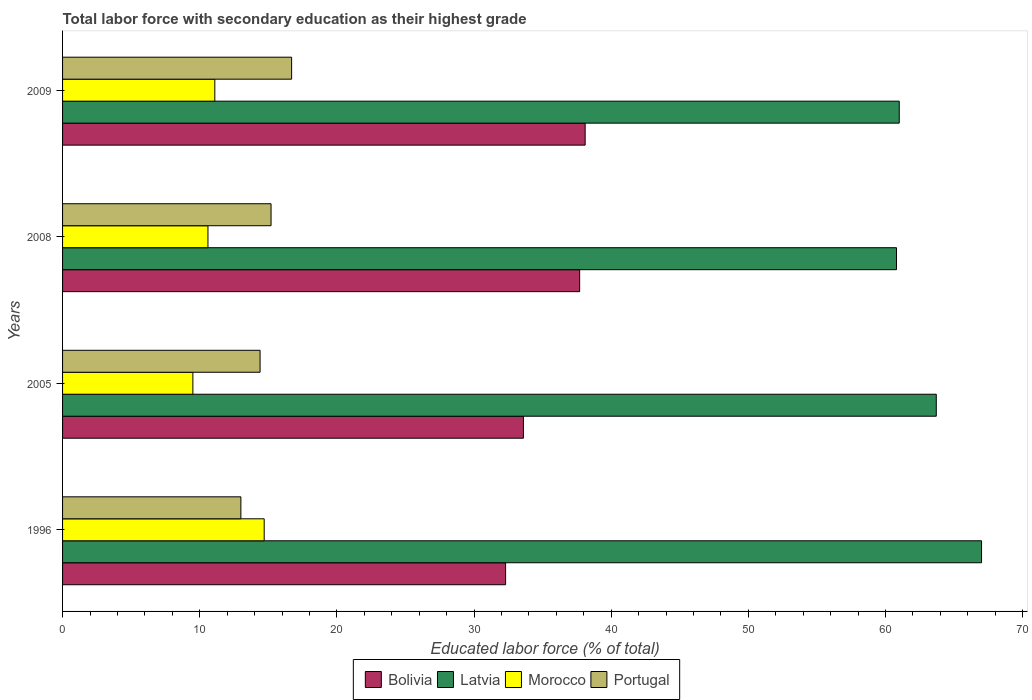How many different coloured bars are there?
Give a very brief answer. 4. Are the number of bars per tick equal to the number of legend labels?
Offer a terse response. Yes. How many bars are there on the 3rd tick from the top?
Your answer should be compact. 4. What is the label of the 1st group of bars from the top?
Give a very brief answer. 2009. What is the percentage of total labor force with primary education in Morocco in 2009?
Ensure brevity in your answer.  11.1. Across all years, what is the maximum percentage of total labor force with primary education in Portugal?
Keep it short and to the point. 16.7. Across all years, what is the minimum percentage of total labor force with primary education in Bolivia?
Offer a terse response. 32.3. In which year was the percentage of total labor force with primary education in Portugal maximum?
Offer a very short reply. 2009. What is the total percentage of total labor force with primary education in Portugal in the graph?
Your answer should be very brief. 59.3. What is the difference between the percentage of total labor force with primary education in Portugal in 1996 and that in 2008?
Keep it short and to the point. -2.2. What is the difference between the percentage of total labor force with primary education in Bolivia in 2005 and the percentage of total labor force with primary education in Portugal in 1996?
Provide a succinct answer. 20.6. What is the average percentage of total labor force with primary education in Portugal per year?
Make the answer very short. 14.83. In the year 1996, what is the difference between the percentage of total labor force with primary education in Bolivia and percentage of total labor force with primary education in Morocco?
Your response must be concise. 17.6. In how many years, is the percentage of total labor force with primary education in Latvia greater than 64 %?
Your answer should be compact. 1. What is the ratio of the percentage of total labor force with primary education in Latvia in 1996 to that in 2009?
Your response must be concise. 1.1. What is the difference between the highest and the second highest percentage of total labor force with primary education in Morocco?
Your answer should be very brief. 3.6. What is the difference between the highest and the lowest percentage of total labor force with primary education in Morocco?
Keep it short and to the point. 5.2. Is the sum of the percentage of total labor force with primary education in Morocco in 2005 and 2009 greater than the maximum percentage of total labor force with primary education in Latvia across all years?
Offer a terse response. No. What does the 3rd bar from the top in 2005 represents?
Give a very brief answer. Latvia. Is it the case that in every year, the sum of the percentage of total labor force with primary education in Portugal and percentage of total labor force with primary education in Bolivia is greater than the percentage of total labor force with primary education in Morocco?
Your answer should be compact. Yes. Where does the legend appear in the graph?
Offer a very short reply. Bottom center. How are the legend labels stacked?
Your answer should be compact. Horizontal. What is the title of the graph?
Give a very brief answer. Total labor force with secondary education as their highest grade. Does "Tanzania" appear as one of the legend labels in the graph?
Provide a short and direct response. No. What is the label or title of the X-axis?
Provide a short and direct response. Educated labor force (% of total). What is the label or title of the Y-axis?
Provide a short and direct response. Years. What is the Educated labor force (% of total) of Bolivia in 1996?
Your answer should be very brief. 32.3. What is the Educated labor force (% of total) of Latvia in 1996?
Keep it short and to the point. 67. What is the Educated labor force (% of total) in Morocco in 1996?
Provide a short and direct response. 14.7. What is the Educated labor force (% of total) in Bolivia in 2005?
Give a very brief answer. 33.6. What is the Educated labor force (% of total) of Latvia in 2005?
Ensure brevity in your answer.  63.7. What is the Educated labor force (% of total) of Morocco in 2005?
Ensure brevity in your answer.  9.5. What is the Educated labor force (% of total) in Portugal in 2005?
Your answer should be very brief. 14.4. What is the Educated labor force (% of total) of Bolivia in 2008?
Your answer should be compact. 37.7. What is the Educated labor force (% of total) in Latvia in 2008?
Offer a very short reply. 60.8. What is the Educated labor force (% of total) in Morocco in 2008?
Your answer should be compact. 10.6. What is the Educated labor force (% of total) of Portugal in 2008?
Make the answer very short. 15.2. What is the Educated labor force (% of total) in Bolivia in 2009?
Make the answer very short. 38.1. What is the Educated labor force (% of total) in Morocco in 2009?
Give a very brief answer. 11.1. What is the Educated labor force (% of total) in Portugal in 2009?
Your response must be concise. 16.7. Across all years, what is the maximum Educated labor force (% of total) of Bolivia?
Your response must be concise. 38.1. Across all years, what is the maximum Educated labor force (% of total) in Latvia?
Your response must be concise. 67. Across all years, what is the maximum Educated labor force (% of total) in Morocco?
Your response must be concise. 14.7. Across all years, what is the maximum Educated labor force (% of total) of Portugal?
Your answer should be very brief. 16.7. Across all years, what is the minimum Educated labor force (% of total) of Bolivia?
Your response must be concise. 32.3. Across all years, what is the minimum Educated labor force (% of total) in Latvia?
Offer a very short reply. 60.8. Across all years, what is the minimum Educated labor force (% of total) of Portugal?
Keep it short and to the point. 13. What is the total Educated labor force (% of total) of Bolivia in the graph?
Provide a short and direct response. 141.7. What is the total Educated labor force (% of total) in Latvia in the graph?
Ensure brevity in your answer.  252.5. What is the total Educated labor force (% of total) in Morocco in the graph?
Offer a terse response. 45.9. What is the total Educated labor force (% of total) in Portugal in the graph?
Your answer should be compact. 59.3. What is the difference between the Educated labor force (% of total) in Latvia in 1996 and that in 2005?
Ensure brevity in your answer.  3.3. What is the difference between the Educated labor force (% of total) of Bolivia in 1996 and that in 2009?
Offer a terse response. -5.8. What is the difference between the Educated labor force (% of total) of Latvia in 1996 and that in 2009?
Ensure brevity in your answer.  6. What is the difference between the Educated labor force (% of total) of Morocco in 1996 and that in 2009?
Provide a succinct answer. 3.6. What is the difference between the Educated labor force (% of total) of Portugal in 1996 and that in 2009?
Ensure brevity in your answer.  -3.7. What is the difference between the Educated labor force (% of total) in Bolivia in 2005 and that in 2008?
Offer a very short reply. -4.1. What is the difference between the Educated labor force (% of total) in Portugal in 2005 and that in 2008?
Keep it short and to the point. -0.8. What is the difference between the Educated labor force (% of total) of Bolivia in 2005 and that in 2009?
Your answer should be very brief. -4.5. What is the difference between the Educated labor force (% of total) of Latvia in 2005 and that in 2009?
Offer a terse response. 2.7. What is the difference between the Educated labor force (% of total) in Morocco in 2005 and that in 2009?
Your answer should be compact. -1.6. What is the difference between the Educated labor force (% of total) of Portugal in 2005 and that in 2009?
Your answer should be compact. -2.3. What is the difference between the Educated labor force (% of total) of Bolivia in 2008 and that in 2009?
Offer a very short reply. -0.4. What is the difference between the Educated labor force (% of total) of Latvia in 2008 and that in 2009?
Offer a terse response. -0.2. What is the difference between the Educated labor force (% of total) of Morocco in 2008 and that in 2009?
Give a very brief answer. -0.5. What is the difference between the Educated labor force (% of total) in Bolivia in 1996 and the Educated labor force (% of total) in Latvia in 2005?
Offer a terse response. -31.4. What is the difference between the Educated labor force (% of total) of Bolivia in 1996 and the Educated labor force (% of total) of Morocco in 2005?
Offer a very short reply. 22.8. What is the difference between the Educated labor force (% of total) of Bolivia in 1996 and the Educated labor force (% of total) of Portugal in 2005?
Provide a short and direct response. 17.9. What is the difference between the Educated labor force (% of total) of Latvia in 1996 and the Educated labor force (% of total) of Morocco in 2005?
Ensure brevity in your answer.  57.5. What is the difference between the Educated labor force (% of total) in Latvia in 1996 and the Educated labor force (% of total) in Portugal in 2005?
Your answer should be compact. 52.6. What is the difference between the Educated labor force (% of total) of Morocco in 1996 and the Educated labor force (% of total) of Portugal in 2005?
Provide a short and direct response. 0.3. What is the difference between the Educated labor force (% of total) in Bolivia in 1996 and the Educated labor force (% of total) in Latvia in 2008?
Your answer should be compact. -28.5. What is the difference between the Educated labor force (% of total) in Bolivia in 1996 and the Educated labor force (% of total) in Morocco in 2008?
Keep it short and to the point. 21.7. What is the difference between the Educated labor force (% of total) in Latvia in 1996 and the Educated labor force (% of total) in Morocco in 2008?
Your answer should be very brief. 56.4. What is the difference between the Educated labor force (% of total) in Latvia in 1996 and the Educated labor force (% of total) in Portugal in 2008?
Make the answer very short. 51.8. What is the difference between the Educated labor force (% of total) of Bolivia in 1996 and the Educated labor force (% of total) of Latvia in 2009?
Your answer should be compact. -28.7. What is the difference between the Educated labor force (% of total) in Bolivia in 1996 and the Educated labor force (% of total) in Morocco in 2009?
Provide a short and direct response. 21.2. What is the difference between the Educated labor force (% of total) in Latvia in 1996 and the Educated labor force (% of total) in Morocco in 2009?
Keep it short and to the point. 55.9. What is the difference between the Educated labor force (% of total) of Latvia in 1996 and the Educated labor force (% of total) of Portugal in 2009?
Make the answer very short. 50.3. What is the difference between the Educated labor force (% of total) in Bolivia in 2005 and the Educated labor force (% of total) in Latvia in 2008?
Keep it short and to the point. -27.2. What is the difference between the Educated labor force (% of total) in Bolivia in 2005 and the Educated labor force (% of total) in Morocco in 2008?
Give a very brief answer. 23. What is the difference between the Educated labor force (% of total) of Latvia in 2005 and the Educated labor force (% of total) of Morocco in 2008?
Offer a very short reply. 53.1. What is the difference between the Educated labor force (% of total) of Latvia in 2005 and the Educated labor force (% of total) of Portugal in 2008?
Offer a terse response. 48.5. What is the difference between the Educated labor force (% of total) of Bolivia in 2005 and the Educated labor force (% of total) of Latvia in 2009?
Your response must be concise. -27.4. What is the difference between the Educated labor force (% of total) in Latvia in 2005 and the Educated labor force (% of total) in Morocco in 2009?
Your answer should be very brief. 52.6. What is the difference between the Educated labor force (% of total) in Latvia in 2005 and the Educated labor force (% of total) in Portugal in 2009?
Ensure brevity in your answer.  47. What is the difference between the Educated labor force (% of total) in Bolivia in 2008 and the Educated labor force (% of total) in Latvia in 2009?
Provide a short and direct response. -23.3. What is the difference between the Educated labor force (% of total) of Bolivia in 2008 and the Educated labor force (% of total) of Morocco in 2009?
Your answer should be very brief. 26.6. What is the difference between the Educated labor force (% of total) of Latvia in 2008 and the Educated labor force (% of total) of Morocco in 2009?
Make the answer very short. 49.7. What is the difference between the Educated labor force (% of total) of Latvia in 2008 and the Educated labor force (% of total) of Portugal in 2009?
Provide a succinct answer. 44.1. What is the average Educated labor force (% of total) in Bolivia per year?
Provide a short and direct response. 35.42. What is the average Educated labor force (% of total) of Latvia per year?
Ensure brevity in your answer.  63.12. What is the average Educated labor force (% of total) in Morocco per year?
Offer a terse response. 11.47. What is the average Educated labor force (% of total) of Portugal per year?
Offer a very short reply. 14.82. In the year 1996, what is the difference between the Educated labor force (% of total) in Bolivia and Educated labor force (% of total) in Latvia?
Offer a terse response. -34.7. In the year 1996, what is the difference between the Educated labor force (% of total) in Bolivia and Educated labor force (% of total) in Portugal?
Give a very brief answer. 19.3. In the year 1996, what is the difference between the Educated labor force (% of total) of Latvia and Educated labor force (% of total) of Morocco?
Provide a short and direct response. 52.3. In the year 1996, what is the difference between the Educated labor force (% of total) in Latvia and Educated labor force (% of total) in Portugal?
Offer a terse response. 54. In the year 1996, what is the difference between the Educated labor force (% of total) of Morocco and Educated labor force (% of total) of Portugal?
Give a very brief answer. 1.7. In the year 2005, what is the difference between the Educated labor force (% of total) of Bolivia and Educated labor force (% of total) of Latvia?
Your response must be concise. -30.1. In the year 2005, what is the difference between the Educated labor force (% of total) in Bolivia and Educated labor force (% of total) in Morocco?
Offer a very short reply. 24.1. In the year 2005, what is the difference between the Educated labor force (% of total) of Latvia and Educated labor force (% of total) of Morocco?
Ensure brevity in your answer.  54.2. In the year 2005, what is the difference between the Educated labor force (% of total) in Latvia and Educated labor force (% of total) in Portugal?
Your response must be concise. 49.3. In the year 2008, what is the difference between the Educated labor force (% of total) of Bolivia and Educated labor force (% of total) of Latvia?
Your response must be concise. -23.1. In the year 2008, what is the difference between the Educated labor force (% of total) of Bolivia and Educated labor force (% of total) of Morocco?
Offer a terse response. 27.1. In the year 2008, what is the difference between the Educated labor force (% of total) in Bolivia and Educated labor force (% of total) in Portugal?
Offer a terse response. 22.5. In the year 2008, what is the difference between the Educated labor force (% of total) of Latvia and Educated labor force (% of total) of Morocco?
Make the answer very short. 50.2. In the year 2008, what is the difference between the Educated labor force (% of total) of Latvia and Educated labor force (% of total) of Portugal?
Give a very brief answer. 45.6. In the year 2009, what is the difference between the Educated labor force (% of total) of Bolivia and Educated labor force (% of total) of Latvia?
Your answer should be very brief. -22.9. In the year 2009, what is the difference between the Educated labor force (% of total) of Bolivia and Educated labor force (% of total) of Portugal?
Your answer should be very brief. 21.4. In the year 2009, what is the difference between the Educated labor force (% of total) in Latvia and Educated labor force (% of total) in Morocco?
Offer a very short reply. 49.9. In the year 2009, what is the difference between the Educated labor force (% of total) of Latvia and Educated labor force (% of total) of Portugal?
Your answer should be very brief. 44.3. In the year 2009, what is the difference between the Educated labor force (% of total) in Morocco and Educated labor force (% of total) in Portugal?
Offer a very short reply. -5.6. What is the ratio of the Educated labor force (% of total) of Bolivia in 1996 to that in 2005?
Keep it short and to the point. 0.96. What is the ratio of the Educated labor force (% of total) of Latvia in 1996 to that in 2005?
Keep it short and to the point. 1.05. What is the ratio of the Educated labor force (% of total) in Morocco in 1996 to that in 2005?
Offer a terse response. 1.55. What is the ratio of the Educated labor force (% of total) of Portugal in 1996 to that in 2005?
Offer a very short reply. 0.9. What is the ratio of the Educated labor force (% of total) of Bolivia in 1996 to that in 2008?
Offer a terse response. 0.86. What is the ratio of the Educated labor force (% of total) in Latvia in 1996 to that in 2008?
Your answer should be compact. 1.1. What is the ratio of the Educated labor force (% of total) of Morocco in 1996 to that in 2008?
Give a very brief answer. 1.39. What is the ratio of the Educated labor force (% of total) of Portugal in 1996 to that in 2008?
Your response must be concise. 0.86. What is the ratio of the Educated labor force (% of total) in Bolivia in 1996 to that in 2009?
Give a very brief answer. 0.85. What is the ratio of the Educated labor force (% of total) in Latvia in 1996 to that in 2009?
Provide a short and direct response. 1.1. What is the ratio of the Educated labor force (% of total) in Morocco in 1996 to that in 2009?
Offer a very short reply. 1.32. What is the ratio of the Educated labor force (% of total) in Portugal in 1996 to that in 2009?
Offer a very short reply. 0.78. What is the ratio of the Educated labor force (% of total) of Bolivia in 2005 to that in 2008?
Your response must be concise. 0.89. What is the ratio of the Educated labor force (% of total) of Latvia in 2005 to that in 2008?
Your answer should be compact. 1.05. What is the ratio of the Educated labor force (% of total) of Morocco in 2005 to that in 2008?
Offer a very short reply. 0.9. What is the ratio of the Educated labor force (% of total) of Bolivia in 2005 to that in 2009?
Provide a short and direct response. 0.88. What is the ratio of the Educated labor force (% of total) of Latvia in 2005 to that in 2009?
Offer a terse response. 1.04. What is the ratio of the Educated labor force (% of total) in Morocco in 2005 to that in 2009?
Provide a succinct answer. 0.86. What is the ratio of the Educated labor force (% of total) in Portugal in 2005 to that in 2009?
Make the answer very short. 0.86. What is the ratio of the Educated labor force (% of total) in Bolivia in 2008 to that in 2009?
Keep it short and to the point. 0.99. What is the ratio of the Educated labor force (% of total) in Latvia in 2008 to that in 2009?
Give a very brief answer. 1. What is the ratio of the Educated labor force (% of total) in Morocco in 2008 to that in 2009?
Your answer should be compact. 0.95. What is the ratio of the Educated labor force (% of total) of Portugal in 2008 to that in 2009?
Make the answer very short. 0.91. What is the difference between the highest and the second highest Educated labor force (% of total) in Bolivia?
Make the answer very short. 0.4. What is the difference between the highest and the second highest Educated labor force (% of total) of Latvia?
Your answer should be very brief. 3.3. What is the difference between the highest and the second highest Educated labor force (% of total) of Morocco?
Make the answer very short. 3.6. What is the difference between the highest and the lowest Educated labor force (% of total) of Bolivia?
Provide a short and direct response. 5.8. What is the difference between the highest and the lowest Educated labor force (% of total) of Latvia?
Give a very brief answer. 6.2. What is the difference between the highest and the lowest Educated labor force (% of total) of Morocco?
Provide a short and direct response. 5.2. What is the difference between the highest and the lowest Educated labor force (% of total) of Portugal?
Your answer should be very brief. 3.7. 